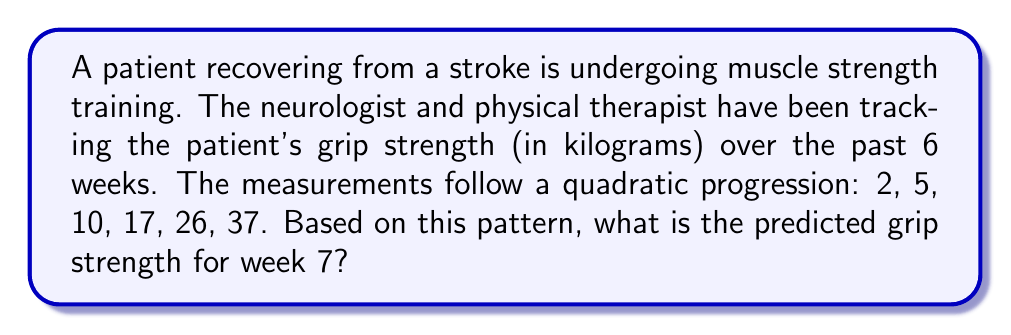What is the answer to this math problem? To solve this problem, we need to identify the pattern in the given sequence and extend it to the next term. Let's approach this step-by-step:

1) First, let's look at the differences between consecutive terms:
   2, 5, 10, 17, 26, 37
      3,  5,  7,  9, 11

2) We notice that the differences are increasing by a constant amount of 2. This suggests a quadratic sequence.

3) For a quadratic sequence, the general form is:
   $a_n = an^2 + bn + c$, where $n$ is the term number (starting from 0).

4) To find $a$, $b$, and $c$, we can use the method of differences:
   - The second difference is constant and equal to $2a$
   - From our sequence: $5 - 3 = 2$, $7 - 5 = 2$, etc.
   - So, $2a = 2$, therefore $a = 1$

5) Now we can set up a system of equations using the first three terms:
   $a_0 = c = 2$
   $a_1 = a + b + c = 5$
   $a_2 = 4a + 2b + c = 10$

6) Substituting known values:
   $c = 2$
   $1 + b + 2 = 5$, so $b = 2$
   $4(1) + 2(2) + 2 = 10$, which confirms our values

7) Therefore, our sequence follows the formula:
   $a_n = n^2 + 2n + 2$

8) For week 7, $n = 6$ (since we start counting from 0):
   $a_6 = 6^2 + 2(6) + 2 = 36 + 12 + 2 = 50$

Thus, the predicted grip strength for week 7 is 50 kg.
Answer: 50 kg 